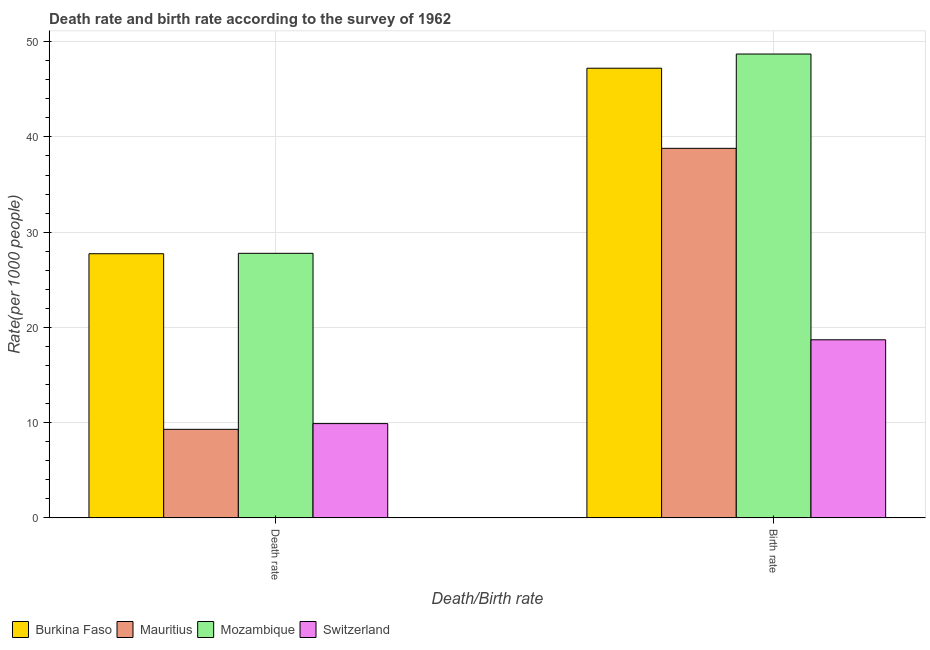How many groups of bars are there?
Your answer should be compact. 2. Are the number of bars per tick equal to the number of legend labels?
Provide a succinct answer. Yes. How many bars are there on the 1st tick from the left?
Your response must be concise. 4. How many bars are there on the 2nd tick from the right?
Give a very brief answer. 4. What is the label of the 1st group of bars from the left?
Make the answer very short. Death rate. What is the birth rate in Mauritius?
Your response must be concise. 38.8. Across all countries, what is the maximum birth rate?
Provide a succinct answer. 48.7. Across all countries, what is the minimum death rate?
Provide a succinct answer. 9.3. In which country was the death rate maximum?
Offer a terse response. Mozambique. In which country was the death rate minimum?
Offer a terse response. Mauritius. What is the total birth rate in the graph?
Keep it short and to the point. 153.41. What is the difference between the birth rate in Mozambique and that in Burkina Faso?
Provide a succinct answer. 1.49. What is the difference between the death rate in Switzerland and the birth rate in Mauritius?
Offer a terse response. -28.9. What is the average birth rate per country?
Make the answer very short. 38.35. What is the difference between the birth rate and death rate in Burkina Faso?
Your response must be concise. 19.48. What is the ratio of the death rate in Switzerland to that in Mauritius?
Ensure brevity in your answer.  1.06. Is the death rate in Mauritius less than that in Burkina Faso?
Make the answer very short. Yes. What does the 2nd bar from the left in Birth rate represents?
Your response must be concise. Mauritius. What does the 4th bar from the right in Death rate represents?
Your answer should be compact. Burkina Faso. How many bars are there?
Make the answer very short. 8. How many countries are there in the graph?
Give a very brief answer. 4. What is the difference between two consecutive major ticks on the Y-axis?
Keep it short and to the point. 10. Are the values on the major ticks of Y-axis written in scientific E-notation?
Ensure brevity in your answer.  No. Does the graph contain any zero values?
Your answer should be very brief. No. Where does the legend appear in the graph?
Your answer should be compact. Bottom left. How are the legend labels stacked?
Your answer should be compact. Horizontal. What is the title of the graph?
Provide a succinct answer. Death rate and birth rate according to the survey of 1962. What is the label or title of the X-axis?
Offer a terse response. Death/Birth rate. What is the label or title of the Y-axis?
Provide a succinct answer. Rate(per 1000 people). What is the Rate(per 1000 people) of Burkina Faso in Death rate?
Give a very brief answer. 27.73. What is the Rate(per 1000 people) in Mozambique in Death rate?
Keep it short and to the point. 27.78. What is the Rate(per 1000 people) of Switzerland in Death rate?
Provide a succinct answer. 9.9. What is the Rate(per 1000 people) of Burkina Faso in Birth rate?
Your response must be concise. 47.21. What is the Rate(per 1000 people) of Mauritius in Birth rate?
Your answer should be compact. 38.8. What is the Rate(per 1000 people) of Mozambique in Birth rate?
Ensure brevity in your answer.  48.7. What is the Rate(per 1000 people) of Switzerland in Birth rate?
Give a very brief answer. 18.7. Across all Death/Birth rate, what is the maximum Rate(per 1000 people) in Burkina Faso?
Offer a very short reply. 47.21. Across all Death/Birth rate, what is the maximum Rate(per 1000 people) in Mauritius?
Your answer should be compact. 38.8. Across all Death/Birth rate, what is the maximum Rate(per 1000 people) of Mozambique?
Ensure brevity in your answer.  48.7. Across all Death/Birth rate, what is the minimum Rate(per 1000 people) in Burkina Faso?
Offer a very short reply. 27.73. Across all Death/Birth rate, what is the minimum Rate(per 1000 people) of Mauritius?
Your answer should be very brief. 9.3. Across all Death/Birth rate, what is the minimum Rate(per 1000 people) in Mozambique?
Provide a succinct answer. 27.78. What is the total Rate(per 1000 people) of Burkina Faso in the graph?
Offer a terse response. 74.94. What is the total Rate(per 1000 people) of Mauritius in the graph?
Give a very brief answer. 48.1. What is the total Rate(per 1000 people) of Mozambique in the graph?
Provide a succinct answer. 76.48. What is the total Rate(per 1000 people) in Switzerland in the graph?
Your response must be concise. 28.6. What is the difference between the Rate(per 1000 people) of Burkina Faso in Death rate and that in Birth rate?
Make the answer very short. -19.48. What is the difference between the Rate(per 1000 people) of Mauritius in Death rate and that in Birth rate?
Provide a short and direct response. -29.5. What is the difference between the Rate(per 1000 people) of Mozambique in Death rate and that in Birth rate?
Your answer should be very brief. -20.92. What is the difference between the Rate(per 1000 people) in Burkina Faso in Death rate and the Rate(per 1000 people) in Mauritius in Birth rate?
Offer a very short reply. -11.06. What is the difference between the Rate(per 1000 people) of Burkina Faso in Death rate and the Rate(per 1000 people) of Mozambique in Birth rate?
Your answer should be very brief. -20.97. What is the difference between the Rate(per 1000 people) in Burkina Faso in Death rate and the Rate(per 1000 people) in Switzerland in Birth rate?
Offer a terse response. 9.04. What is the difference between the Rate(per 1000 people) in Mauritius in Death rate and the Rate(per 1000 people) in Mozambique in Birth rate?
Offer a terse response. -39.4. What is the difference between the Rate(per 1000 people) in Mauritius in Death rate and the Rate(per 1000 people) in Switzerland in Birth rate?
Ensure brevity in your answer.  -9.4. What is the difference between the Rate(per 1000 people) of Mozambique in Death rate and the Rate(per 1000 people) of Switzerland in Birth rate?
Make the answer very short. 9.08. What is the average Rate(per 1000 people) in Burkina Faso per Death/Birth rate?
Make the answer very short. 37.47. What is the average Rate(per 1000 people) in Mauritius per Death/Birth rate?
Your response must be concise. 24.05. What is the average Rate(per 1000 people) of Mozambique per Death/Birth rate?
Keep it short and to the point. 38.24. What is the average Rate(per 1000 people) of Switzerland per Death/Birth rate?
Offer a very short reply. 14.3. What is the difference between the Rate(per 1000 people) in Burkina Faso and Rate(per 1000 people) in Mauritius in Death rate?
Ensure brevity in your answer.  18.43. What is the difference between the Rate(per 1000 people) in Burkina Faso and Rate(per 1000 people) in Mozambique in Death rate?
Your answer should be very brief. -0.04. What is the difference between the Rate(per 1000 people) in Burkina Faso and Rate(per 1000 people) in Switzerland in Death rate?
Your response must be concise. 17.84. What is the difference between the Rate(per 1000 people) of Mauritius and Rate(per 1000 people) of Mozambique in Death rate?
Provide a succinct answer. -18.48. What is the difference between the Rate(per 1000 people) in Mozambique and Rate(per 1000 people) in Switzerland in Death rate?
Your response must be concise. 17.88. What is the difference between the Rate(per 1000 people) of Burkina Faso and Rate(per 1000 people) of Mauritius in Birth rate?
Provide a short and direct response. 8.41. What is the difference between the Rate(per 1000 people) in Burkina Faso and Rate(per 1000 people) in Mozambique in Birth rate?
Provide a short and direct response. -1.49. What is the difference between the Rate(per 1000 people) in Burkina Faso and Rate(per 1000 people) in Switzerland in Birth rate?
Make the answer very short. 28.51. What is the difference between the Rate(per 1000 people) of Mauritius and Rate(per 1000 people) of Mozambique in Birth rate?
Your answer should be compact. -9.9. What is the difference between the Rate(per 1000 people) of Mauritius and Rate(per 1000 people) of Switzerland in Birth rate?
Offer a very short reply. 20.1. What is the difference between the Rate(per 1000 people) of Mozambique and Rate(per 1000 people) of Switzerland in Birth rate?
Keep it short and to the point. 30. What is the ratio of the Rate(per 1000 people) in Burkina Faso in Death rate to that in Birth rate?
Your answer should be very brief. 0.59. What is the ratio of the Rate(per 1000 people) of Mauritius in Death rate to that in Birth rate?
Give a very brief answer. 0.24. What is the ratio of the Rate(per 1000 people) in Mozambique in Death rate to that in Birth rate?
Offer a very short reply. 0.57. What is the ratio of the Rate(per 1000 people) in Switzerland in Death rate to that in Birth rate?
Your answer should be very brief. 0.53. What is the difference between the highest and the second highest Rate(per 1000 people) of Burkina Faso?
Make the answer very short. 19.48. What is the difference between the highest and the second highest Rate(per 1000 people) of Mauritius?
Your answer should be compact. 29.5. What is the difference between the highest and the second highest Rate(per 1000 people) of Mozambique?
Provide a short and direct response. 20.92. What is the difference between the highest and the lowest Rate(per 1000 people) in Burkina Faso?
Keep it short and to the point. 19.48. What is the difference between the highest and the lowest Rate(per 1000 people) of Mauritius?
Your answer should be very brief. 29.5. What is the difference between the highest and the lowest Rate(per 1000 people) of Mozambique?
Provide a short and direct response. 20.92. 